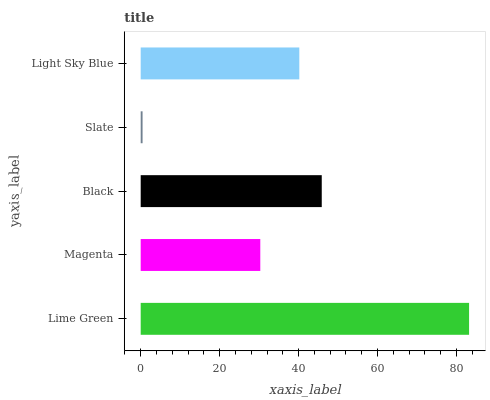Is Slate the minimum?
Answer yes or no. Yes. Is Lime Green the maximum?
Answer yes or no. Yes. Is Magenta the minimum?
Answer yes or no. No. Is Magenta the maximum?
Answer yes or no. No. Is Lime Green greater than Magenta?
Answer yes or no. Yes. Is Magenta less than Lime Green?
Answer yes or no. Yes. Is Magenta greater than Lime Green?
Answer yes or no. No. Is Lime Green less than Magenta?
Answer yes or no. No. Is Light Sky Blue the high median?
Answer yes or no. Yes. Is Light Sky Blue the low median?
Answer yes or no. Yes. Is Black the high median?
Answer yes or no. No. Is Slate the low median?
Answer yes or no. No. 